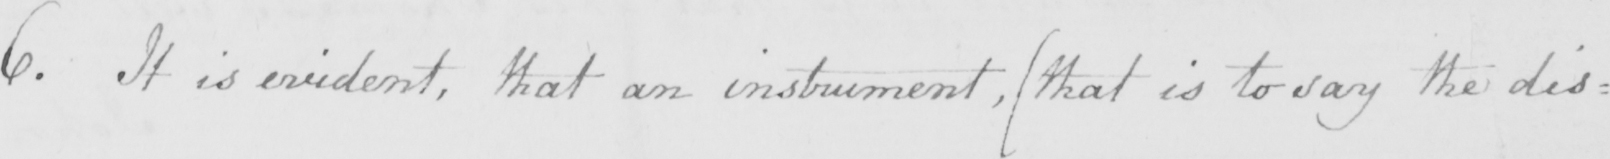Can you tell me what this handwritten text says? 6 . It is evident , that an instrument ,  ( that is to say the dis= 